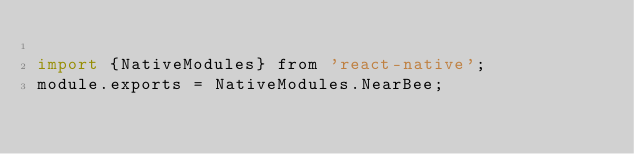<code> <loc_0><loc_0><loc_500><loc_500><_JavaScript_>
import {NativeModules} from 'react-native';
module.exports = NativeModules.NearBee;</code> 